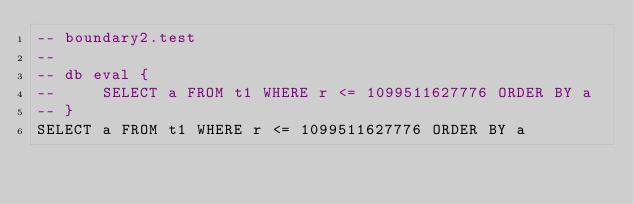Convert code to text. <code><loc_0><loc_0><loc_500><loc_500><_SQL_>-- boundary2.test
-- 
-- db eval {
--     SELECT a FROM t1 WHERE r <= 1099511627776 ORDER BY a
-- }
SELECT a FROM t1 WHERE r <= 1099511627776 ORDER BY a</code> 